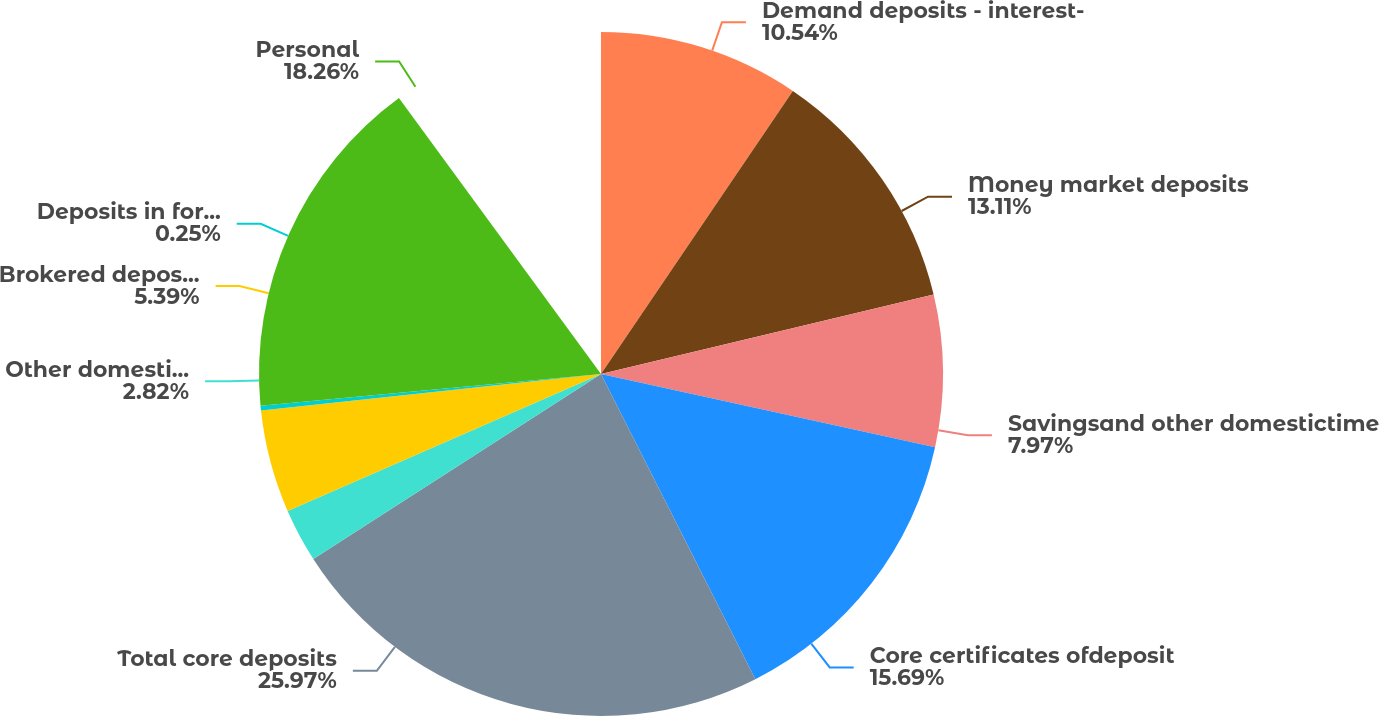Convert chart to OTSL. <chart><loc_0><loc_0><loc_500><loc_500><pie_chart><fcel>Demand deposits - interest-<fcel>Money market deposits<fcel>Savingsand other domestictime<fcel>Core certificates ofdeposit<fcel>Total core deposits<fcel>Other domestictime deposits of<fcel>Brokered deposits and<fcel>Deposits in foreignoffices<fcel>Personal<nl><fcel>10.54%<fcel>13.11%<fcel>7.97%<fcel>15.69%<fcel>25.98%<fcel>2.82%<fcel>5.39%<fcel>0.25%<fcel>18.26%<nl></chart> 